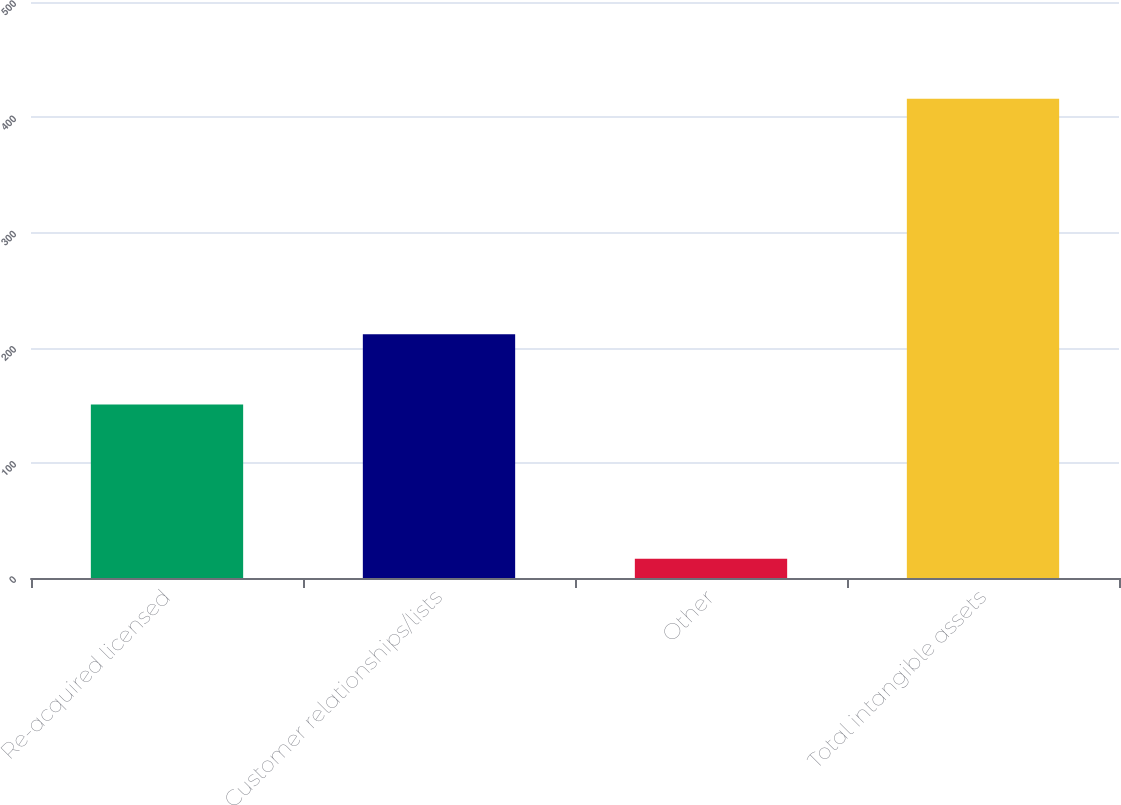<chart> <loc_0><loc_0><loc_500><loc_500><bar_chart><fcel>Re-acquired licensed<fcel>Customer relationships/lists<fcel>Other<fcel>Total intangible assets<nl><fcel>150.7<fcel>211.5<fcel>16.7<fcel>416<nl></chart> 